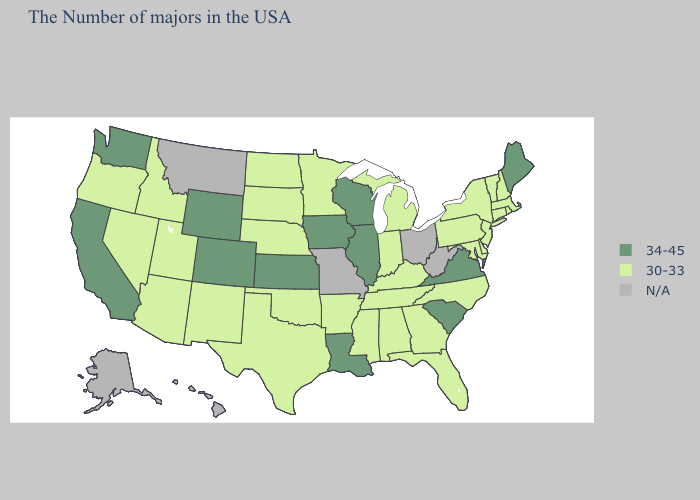Does Oklahoma have the highest value in the South?
Keep it brief. No. Which states have the lowest value in the USA?
Keep it brief. Massachusetts, Rhode Island, New Hampshire, Vermont, Connecticut, New York, New Jersey, Delaware, Maryland, Pennsylvania, North Carolina, Florida, Georgia, Michigan, Kentucky, Indiana, Alabama, Tennessee, Mississippi, Arkansas, Minnesota, Nebraska, Oklahoma, Texas, South Dakota, North Dakota, New Mexico, Utah, Arizona, Idaho, Nevada, Oregon. Does the first symbol in the legend represent the smallest category?
Short answer required. No. Does South Carolina have the lowest value in the USA?
Keep it brief. No. Does Louisiana have the lowest value in the South?
Concise answer only. No. Does Tennessee have the lowest value in the USA?
Give a very brief answer. Yes. Is the legend a continuous bar?
Concise answer only. No. What is the value of Rhode Island?
Quick response, please. 30-33. Which states have the lowest value in the USA?
Concise answer only. Massachusetts, Rhode Island, New Hampshire, Vermont, Connecticut, New York, New Jersey, Delaware, Maryland, Pennsylvania, North Carolina, Florida, Georgia, Michigan, Kentucky, Indiana, Alabama, Tennessee, Mississippi, Arkansas, Minnesota, Nebraska, Oklahoma, Texas, South Dakota, North Dakota, New Mexico, Utah, Arizona, Idaho, Nevada, Oregon. What is the value of Mississippi?
Quick response, please. 30-33. Name the states that have a value in the range N/A?
Short answer required. West Virginia, Ohio, Missouri, Montana, Alaska, Hawaii. 